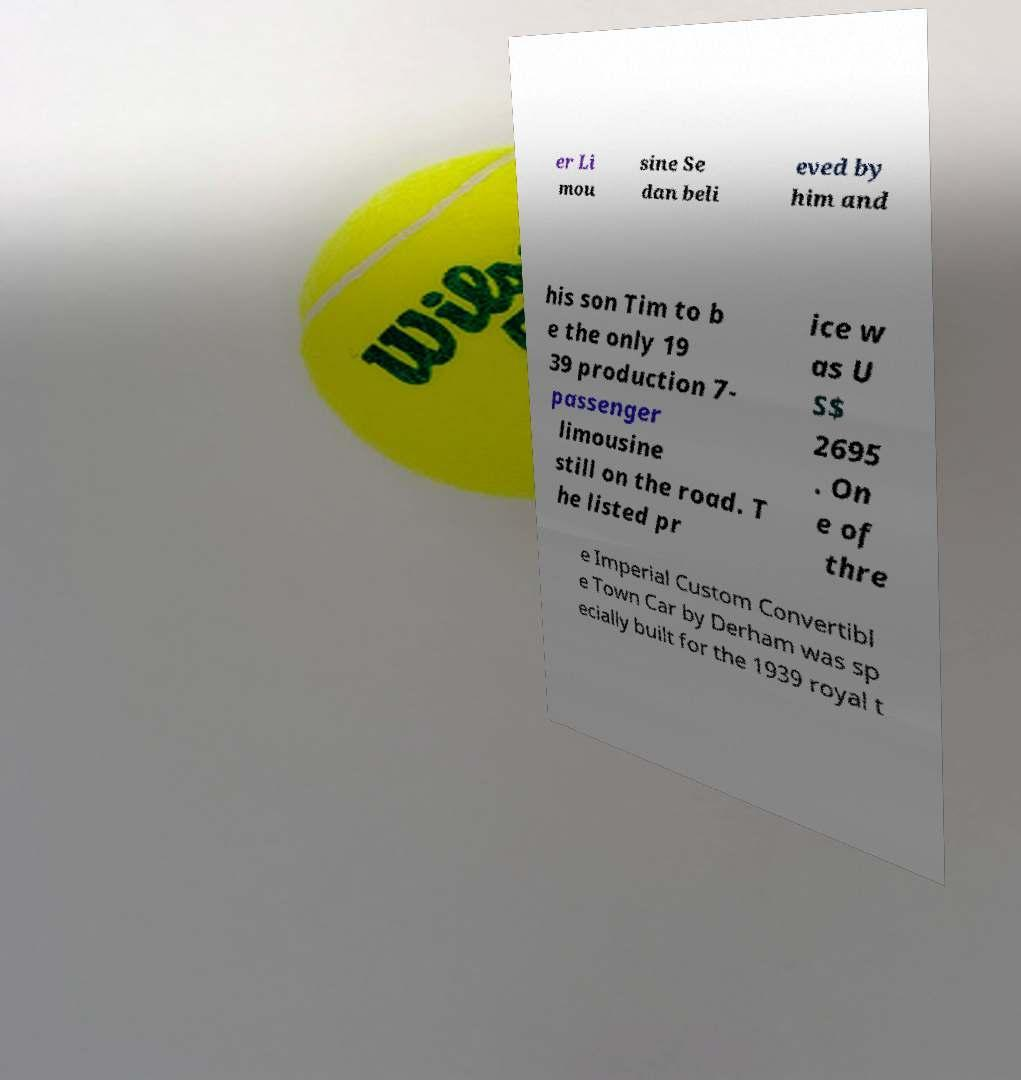There's text embedded in this image that I need extracted. Can you transcribe it verbatim? er Li mou sine Se dan beli eved by him and his son Tim to b e the only 19 39 production 7- passenger limousine still on the road. T he listed pr ice w as U S$ 2695 . On e of thre e Imperial Custom Convertibl e Town Car by Derham was sp ecially built for the 1939 royal t 